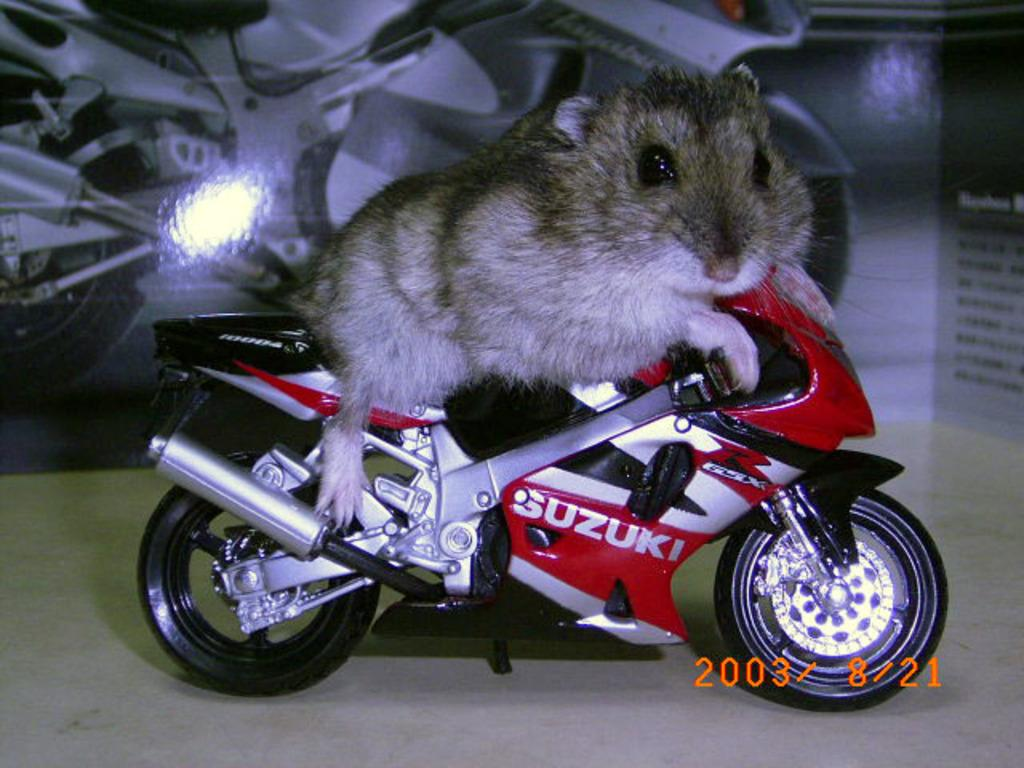What animal is present in the image? There is a rat in the image. What is the rat doing or interacting with in the image? The rat is on a toy bike. What color are the clouds in the image? There are no clouds present in the image; it features a rat on a toy bike. What type of horse can be seen in the image? There is no horse present in the image; it features a rat on a toy bike. 